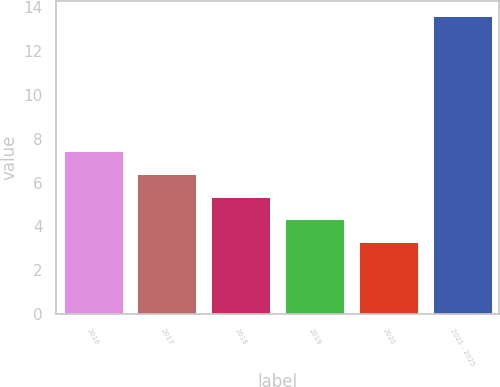<chart> <loc_0><loc_0><loc_500><loc_500><bar_chart><fcel>2016<fcel>2017<fcel>2018<fcel>2019<fcel>2020<fcel>2021 - 2025<nl><fcel>7.42<fcel>6.39<fcel>5.36<fcel>4.33<fcel>3.3<fcel>13.6<nl></chart> 